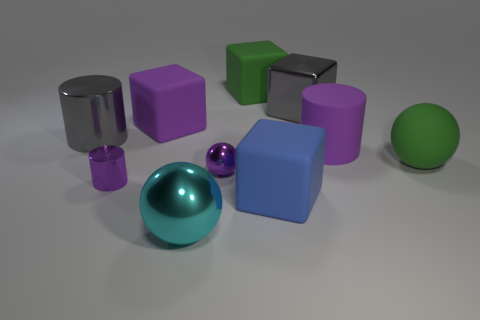Does the small metal object that is in front of the purple metal ball have the same color as the big cylinder to the right of the blue matte cube?
Give a very brief answer. Yes. There is a purple thing that is the same shape as the cyan shiny object; what material is it?
Your response must be concise. Metal. What is the material of the cylinder that is the same color as the big metallic block?
Provide a succinct answer. Metal. Is the number of large purple matte cylinders less than the number of tiny purple objects?
Keep it short and to the point. Yes. Is the color of the cylinder that is in front of the green sphere the same as the small sphere?
Your response must be concise. Yes. What color is the big ball that is made of the same material as the purple block?
Offer a very short reply. Green. Is the matte ball the same size as the purple metallic ball?
Provide a succinct answer. No. What is the large blue block made of?
Make the answer very short. Rubber. There is another ball that is the same size as the cyan metallic ball; what is it made of?
Your response must be concise. Rubber. Are there any gray matte blocks that have the same size as the blue rubber block?
Your response must be concise. No. 